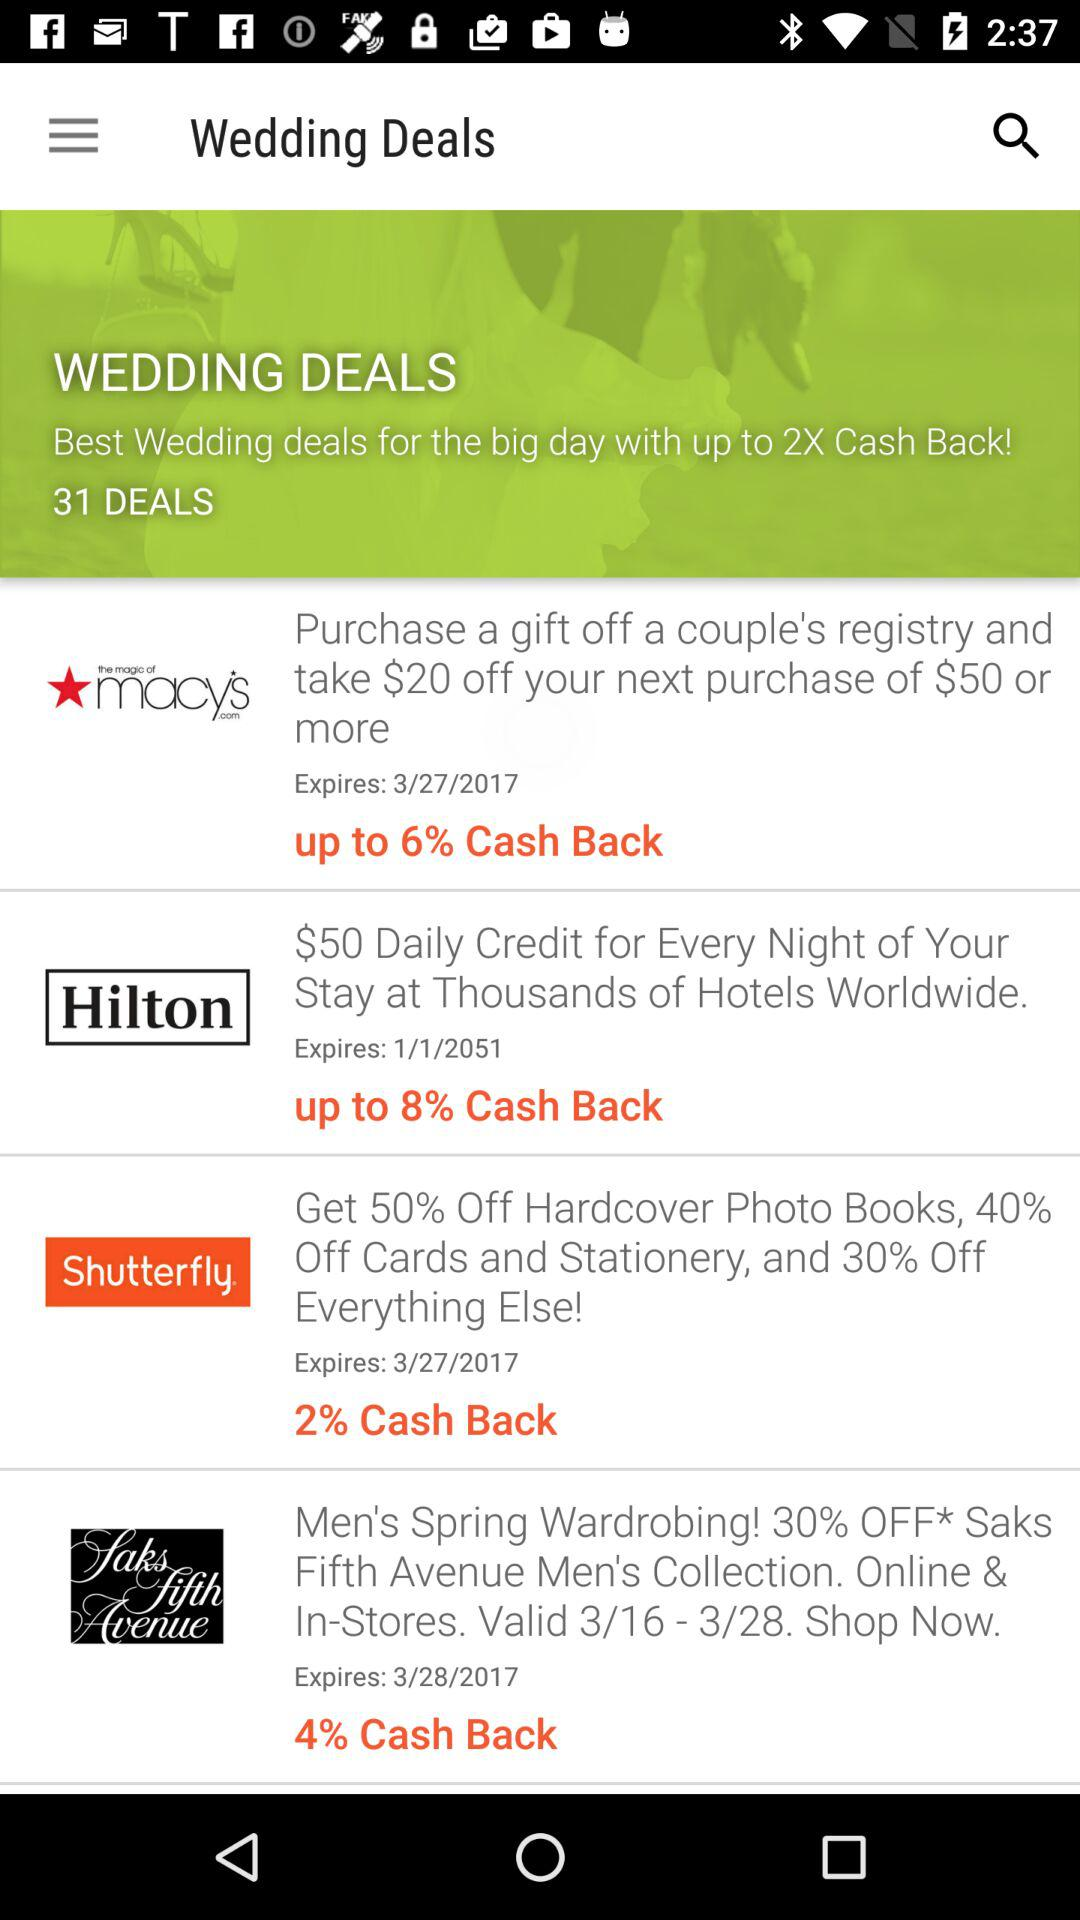Up to how much cashback is given on the Shutterfly coupon? The cashback is 2%. 